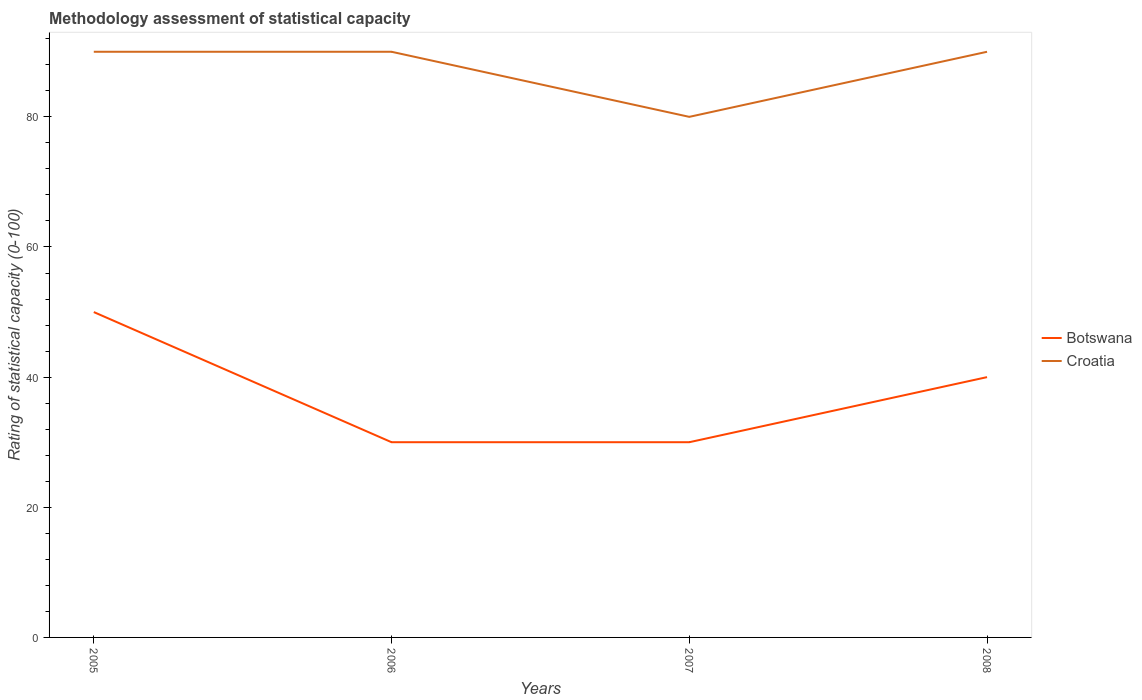Is the number of lines equal to the number of legend labels?
Ensure brevity in your answer.  Yes. Across all years, what is the maximum rating of statistical capacity in Botswana?
Your answer should be very brief. 30. In which year was the rating of statistical capacity in Croatia maximum?
Provide a succinct answer. 2007. What is the total rating of statistical capacity in Botswana in the graph?
Offer a very short reply. 10. What is the difference between the highest and the second highest rating of statistical capacity in Botswana?
Your response must be concise. 20. Is the rating of statistical capacity in Botswana strictly greater than the rating of statistical capacity in Croatia over the years?
Provide a succinct answer. Yes. What is the difference between two consecutive major ticks on the Y-axis?
Offer a very short reply. 20. Where does the legend appear in the graph?
Keep it short and to the point. Center right. What is the title of the graph?
Offer a very short reply. Methodology assessment of statistical capacity. Does "Cameroon" appear as one of the legend labels in the graph?
Your response must be concise. No. What is the label or title of the Y-axis?
Offer a terse response. Rating of statistical capacity (0-100). What is the Rating of statistical capacity (0-100) in Croatia in 2006?
Provide a succinct answer. 90. What is the Rating of statistical capacity (0-100) of Croatia in 2007?
Provide a short and direct response. 80. What is the Rating of statistical capacity (0-100) in Botswana in 2008?
Provide a succinct answer. 40. Across all years, what is the maximum Rating of statistical capacity (0-100) of Croatia?
Make the answer very short. 90. Across all years, what is the minimum Rating of statistical capacity (0-100) of Botswana?
Ensure brevity in your answer.  30. Across all years, what is the minimum Rating of statistical capacity (0-100) of Croatia?
Your response must be concise. 80. What is the total Rating of statistical capacity (0-100) in Botswana in the graph?
Make the answer very short. 150. What is the total Rating of statistical capacity (0-100) of Croatia in the graph?
Provide a short and direct response. 350. What is the difference between the Rating of statistical capacity (0-100) of Botswana in 2005 and that in 2006?
Provide a short and direct response. 20. What is the difference between the Rating of statistical capacity (0-100) in Botswana in 2006 and that in 2008?
Your response must be concise. -10. What is the difference between the Rating of statistical capacity (0-100) in Croatia in 2006 and that in 2008?
Keep it short and to the point. 0. What is the difference between the Rating of statistical capacity (0-100) of Botswana in 2005 and the Rating of statistical capacity (0-100) of Croatia in 2006?
Offer a terse response. -40. What is the difference between the Rating of statistical capacity (0-100) in Botswana in 2005 and the Rating of statistical capacity (0-100) in Croatia in 2008?
Make the answer very short. -40. What is the difference between the Rating of statistical capacity (0-100) of Botswana in 2006 and the Rating of statistical capacity (0-100) of Croatia in 2008?
Offer a terse response. -60. What is the difference between the Rating of statistical capacity (0-100) in Botswana in 2007 and the Rating of statistical capacity (0-100) in Croatia in 2008?
Offer a very short reply. -60. What is the average Rating of statistical capacity (0-100) of Botswana per year?
Ensure brevity in your answer.  37.5. What is the average Rating of statistical capacity (0-100) in Croatia per year?
Provide a short and direct response. 87.5. In the year 2005, what is the difference between the Rating of statistical capacity (0-100) in Botswana and Rating of statistical capacity (0-100) in Croatia?
Provide a succinct answer. -40. In the year 2006, what is the difference between the Rating of statistical capacity (0-100) of Botswana and Rating of statistical capacity (0-100) of Croatia?
Your answer should be very brief. -60. In the year 2007, what is the difference between the Rating of statistical capacity (0-100) in Botswana and Rating of statistical capacity (0-100) in Croatia?
Ensure brevity in your answer.  -50. What is the ratio of the Rating of statistical capacity (0-100) of Croatia in 2005 to that in 2006?
Your answer should be very brief. 1. What is the ratio of the Rating of statistical capacity (0-100) in Botswana in 2005 to that in 2007?
Your answer should be compact. 1.67. What is the ratio of the Rating of statistical capacity (0-100) in Croatia in 2005 to that in 2008?
Offer a very short reply. 1. What is the ratio of the Rating of statistical capacity (0-100) of Botswana in 2006 to that in 2007?
Keep it short and to the point. 1. What is the difference between the highest and the second highest Rating of statistical capacity (0-100) of Botswana?
Make the answer very short. 10. What is the difference between the highest and the second highest Rating of statistical capacity (0-100) in Croatia?
Provide a succinct answer. 0. What is the difference between the highest and the lowest Rating of statistical capacity (0-100) in Botswana?
Keep it short and to the point. 20. 